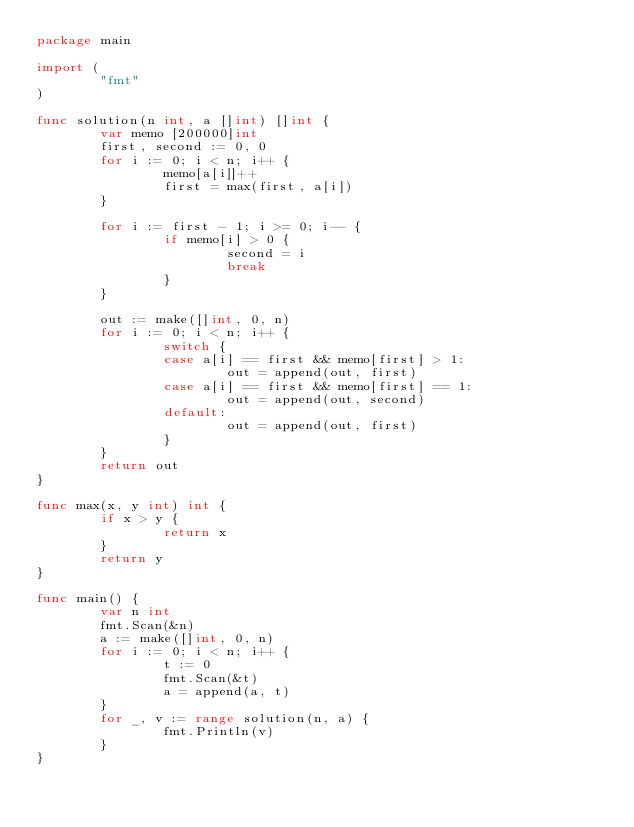Convert code to text. <code><loc_0><loc_0><loc_500><loc_500><_Go_>package main

import (
        "fmt"
)

func solution(n int, a []int) []int {
        var memo [200000]int
        first, second := 0, 0
        for i := 0; i < n; i++ {
                memo[a[i]]++
                first = max(first, a[i])
        }

        for i := first - 1; i >= 0; i-- {
                if memo[i] > 0 {
                        second = i
                        break
                }
        }

        out := make([]int, 0, n)
        for i := 0; i < n; i++ {
                switch {
                case a[i] == first && memo[first] > 1:
                        out = append(out, first)
                case a[i] == first && memo[first] == 1:
                        out = append(out, second)
                default:
                        out = append(out, first)
                }
        }
        return out
}

func max(x, y int) int {
        if x > y {
                return x
        }
        return y
}

func main() {
        var n int
        fmt.Scan(&n)
        a := make([]int, 0, n)
        for i := 0; i < n; i++ {
                t := 0
                fmt.Scan(&t)
                a = append(a, t)
        }
        for _, v := range solution(n, a) {
                fmt.Println(v)
        }
}</code> 